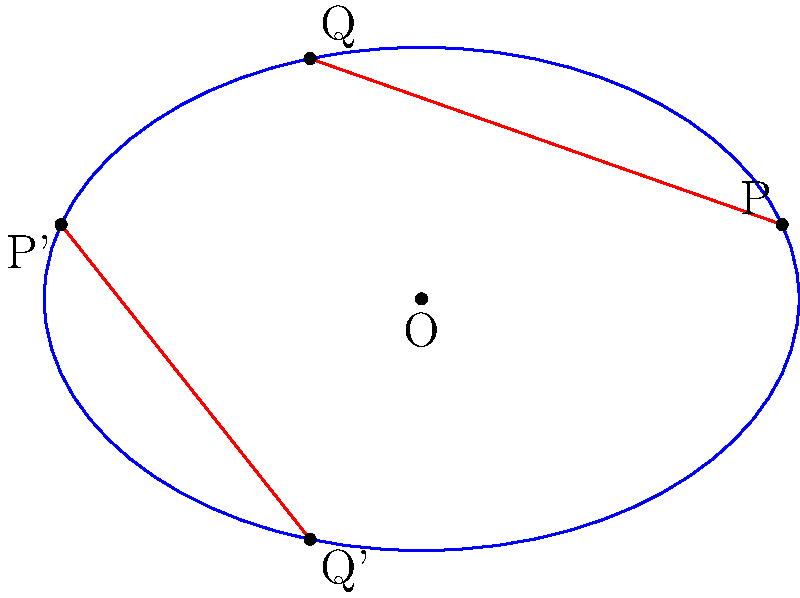In the context of elliptic geometry, consider the image above showing an ellipse representing a projective plane. Two "parallel" lines are drawn in red. How many times do these "parallel" lines intersect, and what does this reveal about the nature of parallel lines in elliptic geometry? Let's approach this step-by-step:

1) In Euclidean geometry, parallel lines never intersect. However, elliptic geometry is a non-Euclidean geometry where the concept of parallelism is different.

2) The ellipse in the image represents a model of the projective plane, which is a way to visualize elliptic geometry.

3) In this model, "lines" are represented by great circles on the surface of a sphere, which appear as closed curves (like the red lines) when projected onto the plane.

4) We can see that the two red lines intersect at two points: once at the top of the ellipse and once at the bottom.

5) These intersection points represent the same point in elliptic geometry, as opposite points on the ellipse are identified with each other in this model.

6) Therefore, in elliptic geometry, these "parallel" lines actually intersect at a single point.

7) This is a fundamental property of elliptic geometry: any two distinct lines always intersect at exactly one point.

8) This property contradicts Euclid's parallel postulate, which is what makes elliptic geometry a non-Euclidean geometry.

9) In the context of our persona, we could think of this as similar to how traditional Italian recipes might seem to have "parallel" or separate techniques, but they often intersect or come together in unexpected ways, creating unique flavors and textures.
Answer: The "parallel" lines intersect once, revealing that in elliptic geometry, all lines intersect. 